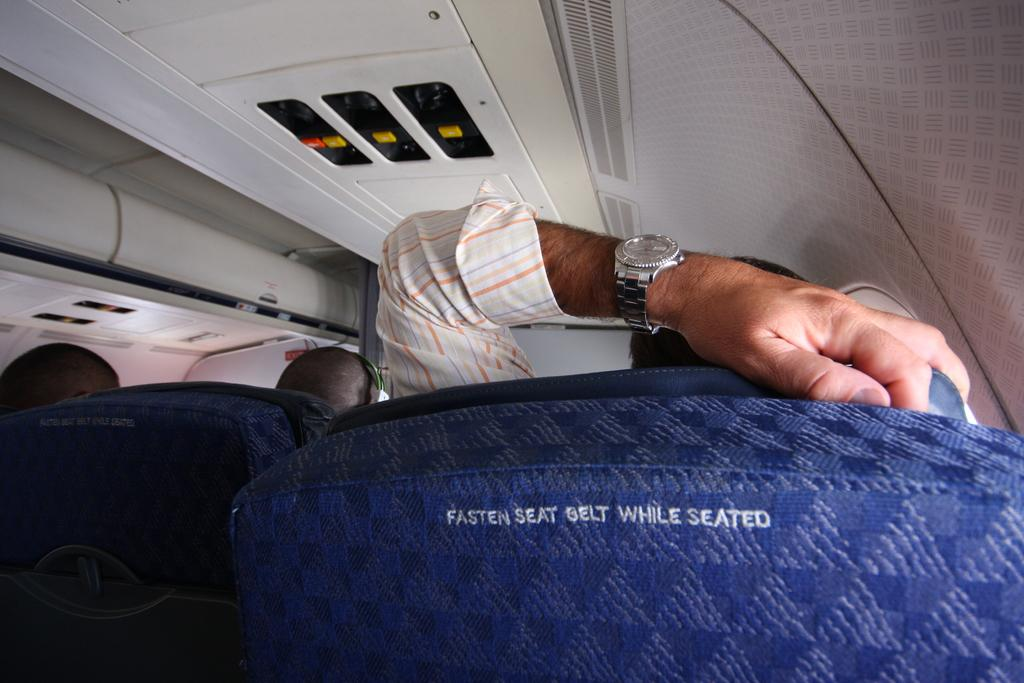<image>
Present a compact description of the photo's key features. A blue airplane seat that reads Fasten Seat Belt While Seated. 